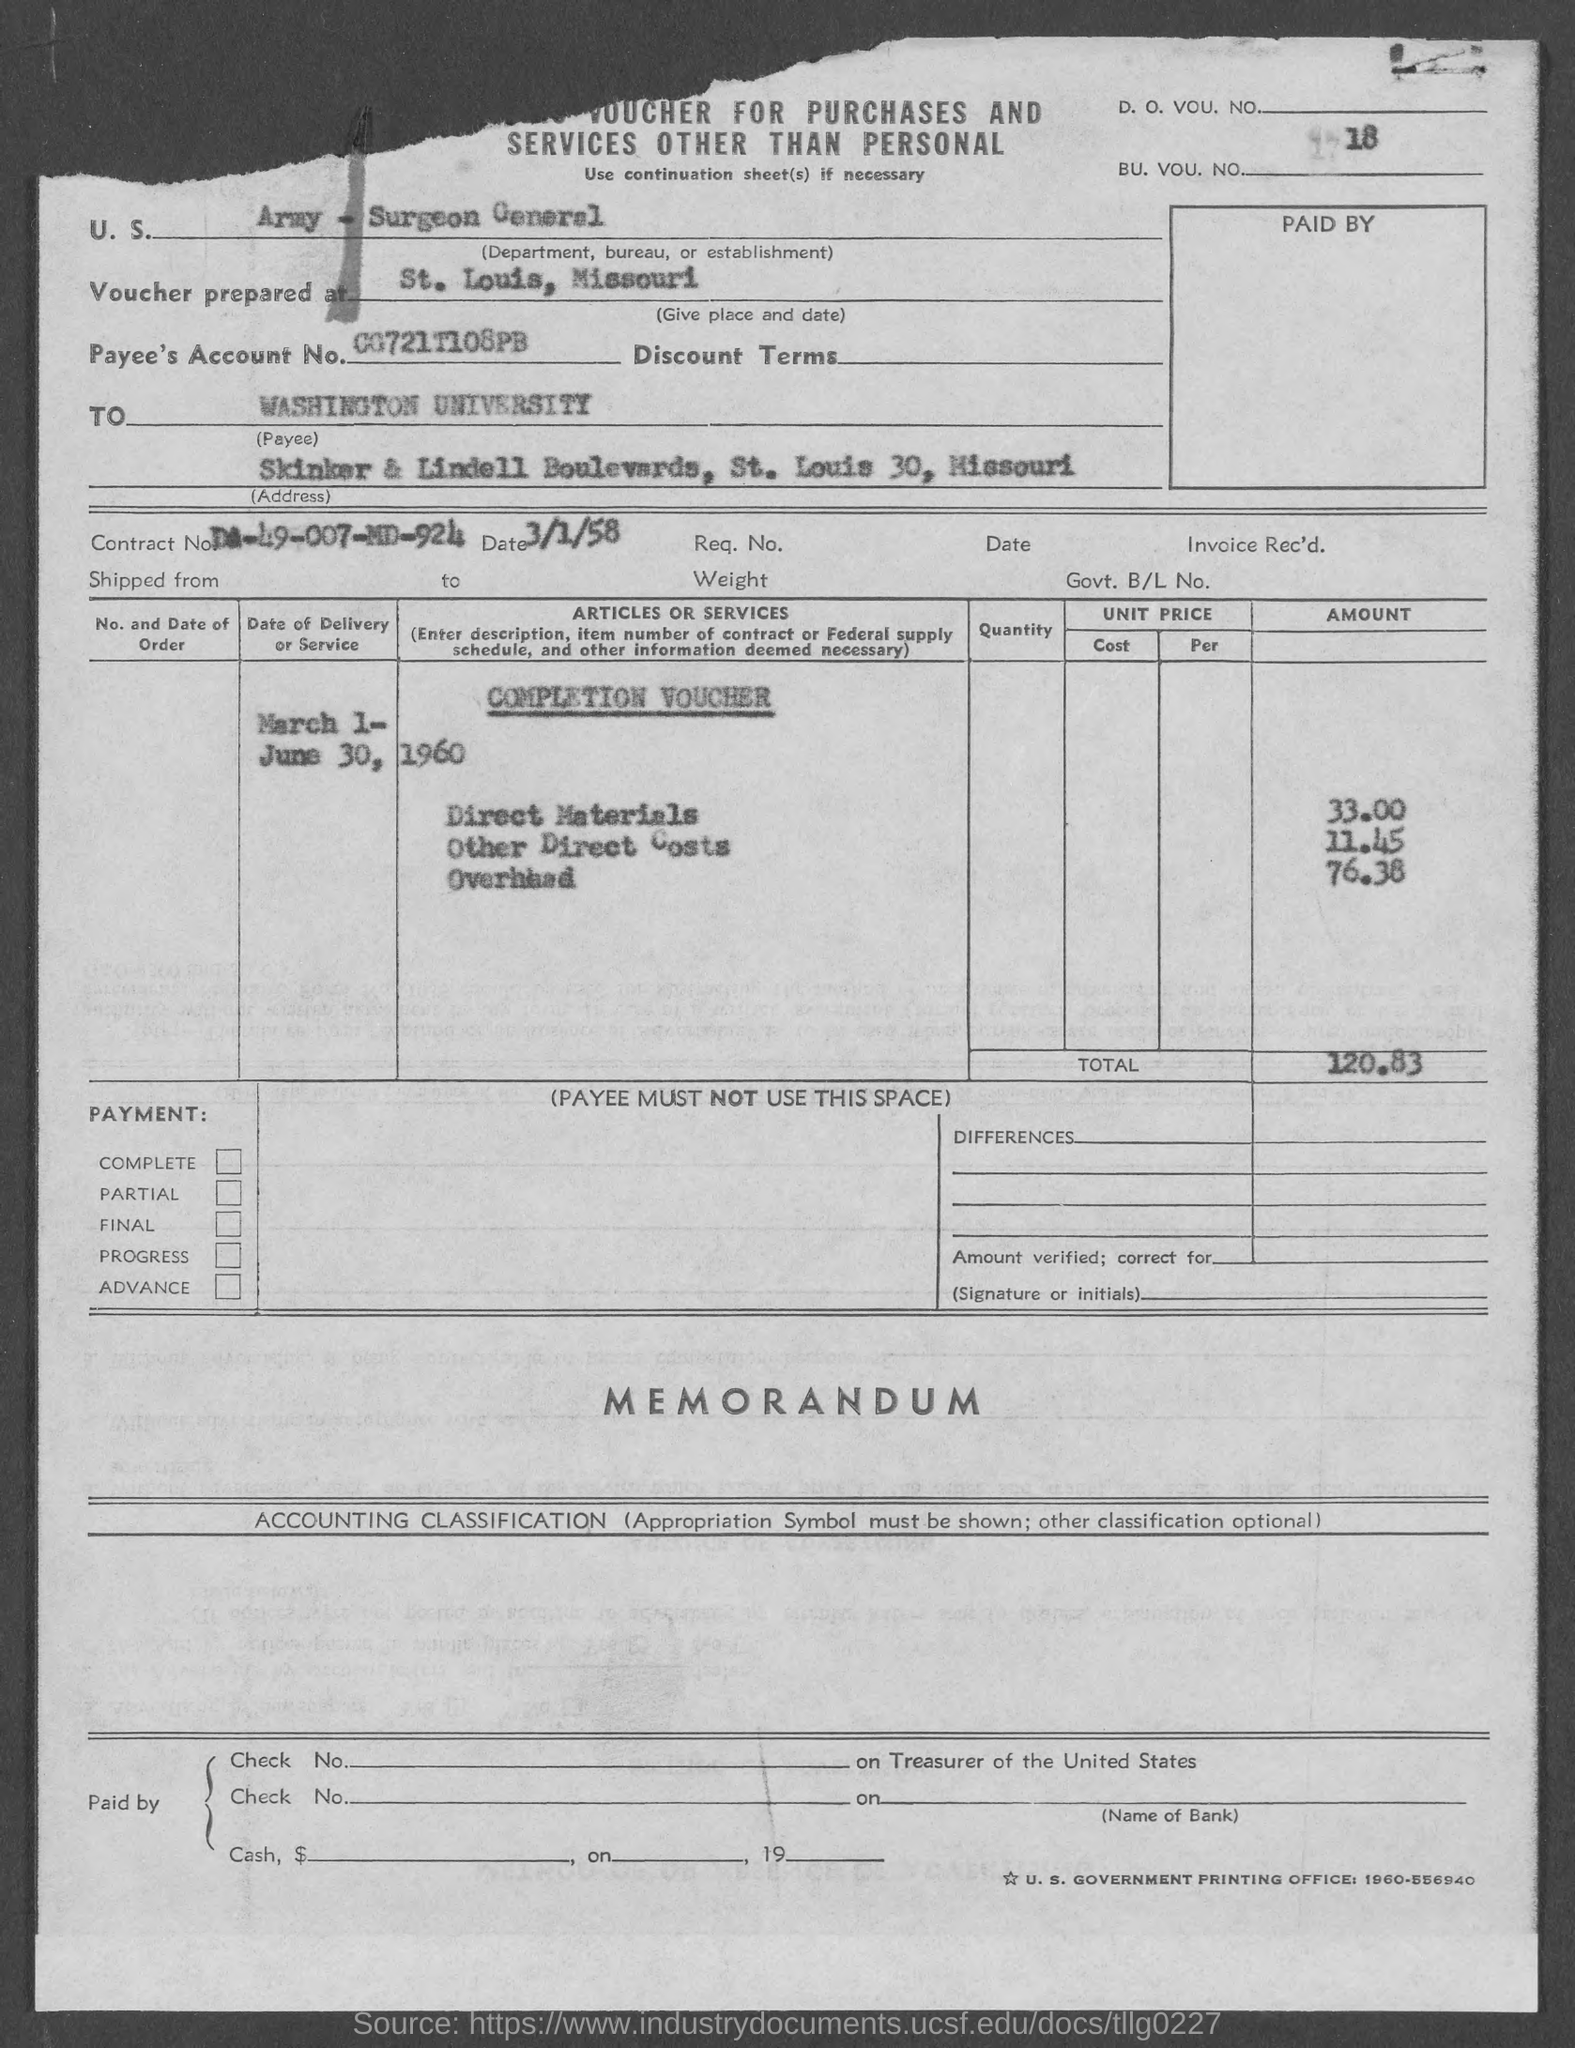What is the payee's account no.?
Your answer should be compact. 00721T108PB. What is the bu. vou. no ?
Provide a short and direct response. 18. 